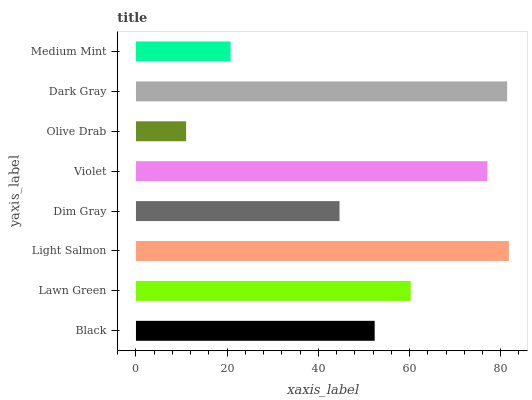Is Olive Drab the minimum?
Answer yes or no. Yes. Is Light Salmon the maximum?
Answer yes or no. Yes. Is Lawn Green the minimum?
Answer yes or no. No. Is Lawn Green the maximum?
Answer yes or no. No. Is Lawn Green greater than Black?
Answer yes or no. Yes. Is Black less than Lawn Green?
Answer yes or no. Yes. Is Black greater than Lawn Green?
Answer yes or no. No. Is Lawn Green less than Black?
Answer yes or no. No. Is Lawn Green the high median?
Answer yes or no. Yes. Is Black the low median?
Answer yes or no. Yes. Is Violet the high median?
Answer yes or no. No. Is Violet the low median?
Answer yes or no. No. 